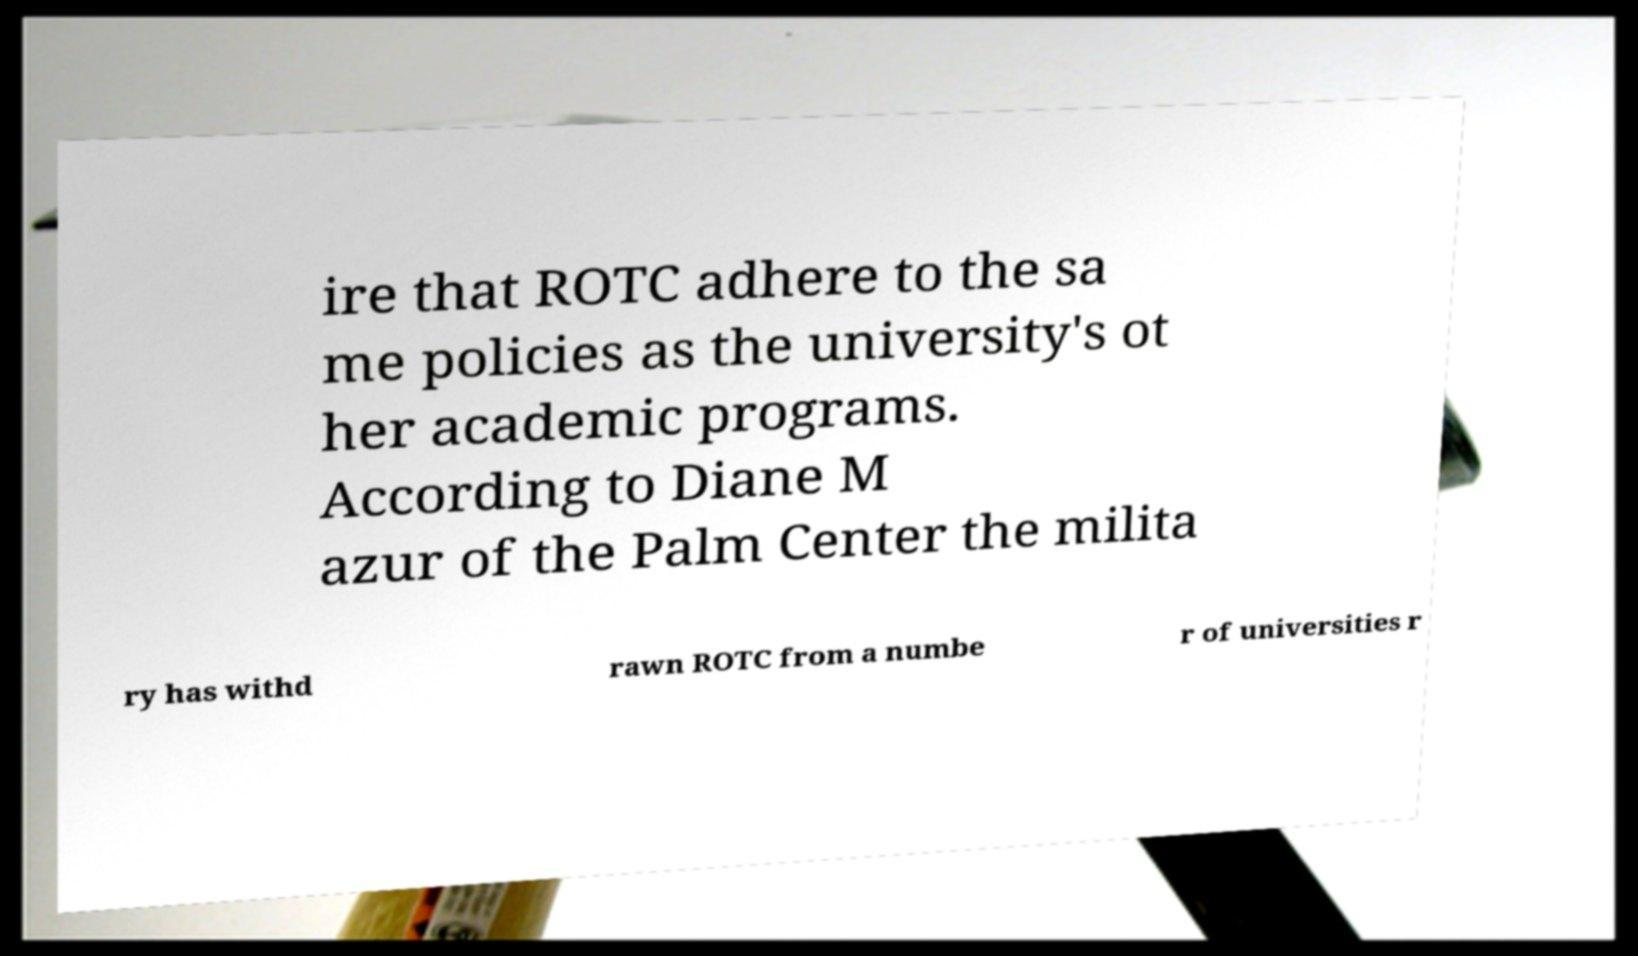Can you accurately transcribe the text from the provided image for me? ire that ROTC adhere to the sa me policies as the university's ot her academic programs. According to Diane M azur of the Palm Center the milita ry has withd rawn ROTC from a numbe r of universities r 